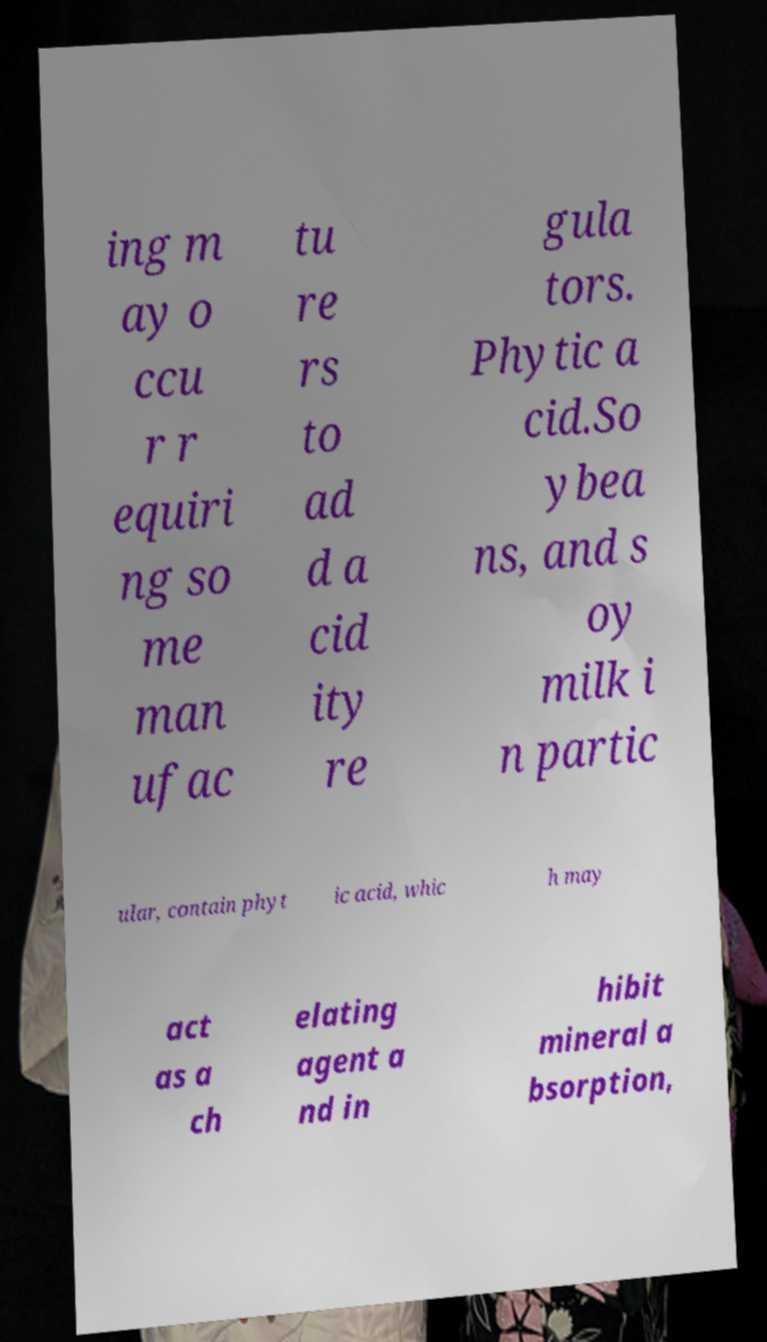Could you extract and type out the text from this image? ing m ay o ccu r r equiri ng so me man ufac tu re rs to ad d a cid ity re gula tors. Phytic a cid.So ybea ns, and s oy milk i n partic ular, contain phyt ic acid, whic h may act as a ch elating agent a nd in hibit mineral a bsorption, 